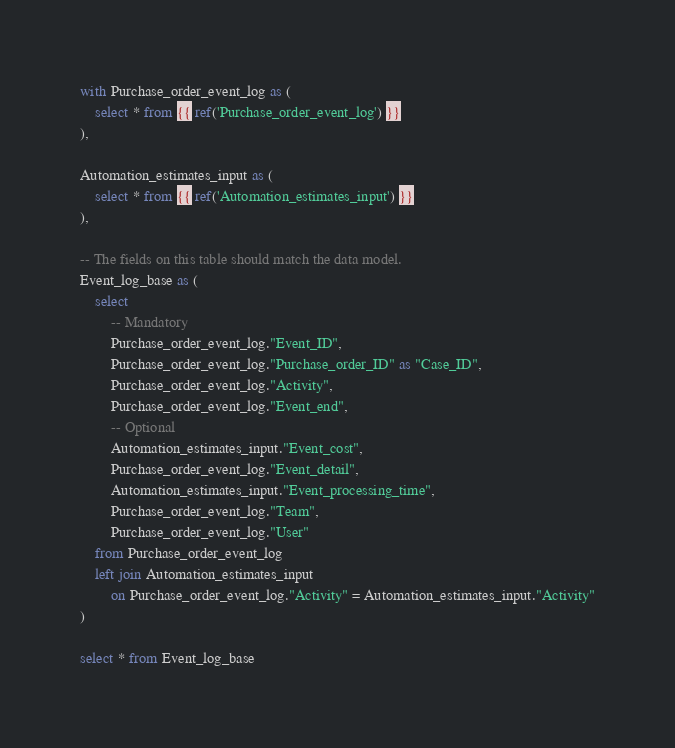Convert code to text. <code><loc_0><loc_0><loc_500><loc_500><_SQL_>with Purchase_order_event_log as (
    select * from {{ ref('Purchase_order_event_log') }}
),

Automation_estimates_input as (
    select * from {{ ref('Automation_estimates_input') }}
),

-- The fields on this table should match the data model.
Event_log_base as (
    select
        -- Mandatory
        Purchase_order_event_log."Event_ID",
        Purchase_order_event_log."Purchase_order_ID" as "Case_ID",
        Purchase_order_event_log."Activity",
        Purchase_order_event_log."Event_end",
        -- Optional
        Automation_estimates_input."Event_cost",
        Purchase_order_event_log."Event_detail",
        Automation_estimates_input."Event_processing_time",
        Purchase_order_event_log."Team",
        Purchase_order_event_log."User"
    from Purchase_order_event_log
    left join Automation_estimates_input
        on Purchase_order_event_log."Activity" = Automation_estimates_input."Activity"
)

select * from Event_log_base
</code> 